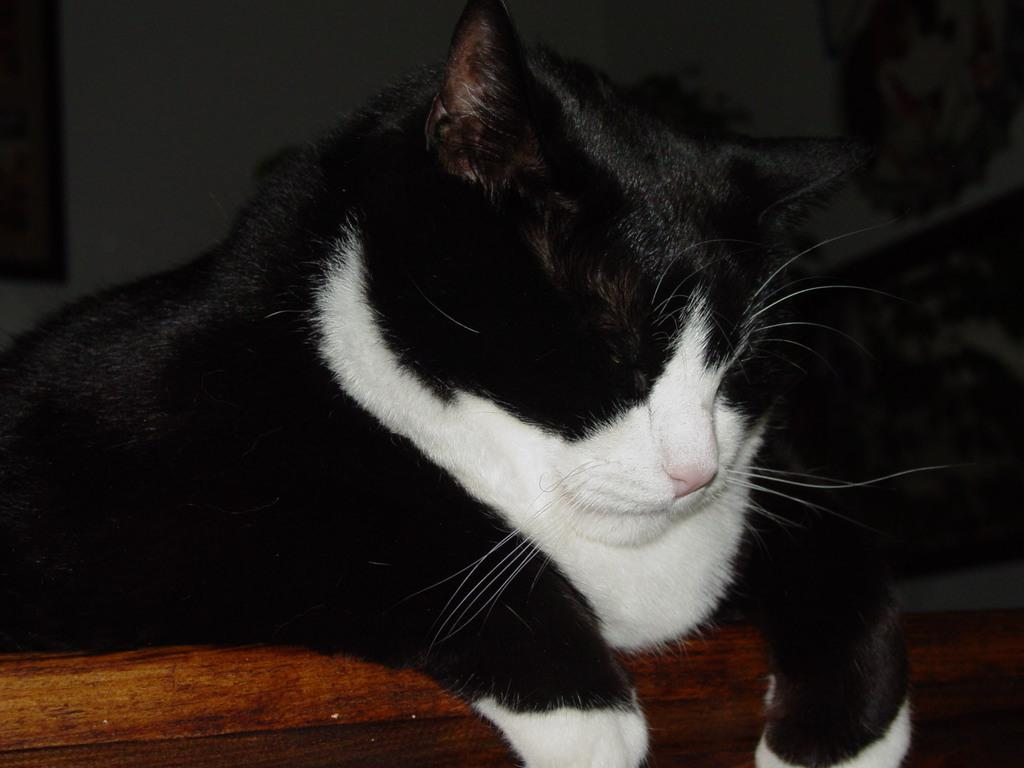What is the main subject in the foreground of the picture? There is a cat in the foreground of the picture. What is the cat doing in the image? The cat is sleeping. On what type of surface is the cat resting? The cat is on a wooden surface. What can be seen in the background of the picture? There is a wall in the background of the picture. What is the cat attempting to measure in the image? The cat is not attempting to measure anything in the image; it is sleeping. 